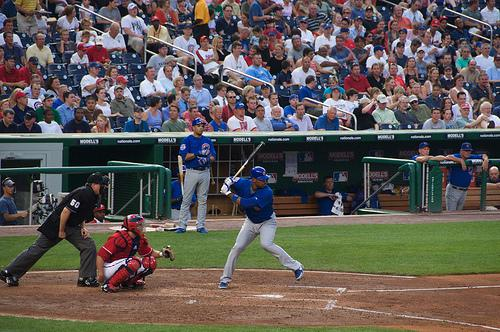Question: where are they at?
Choices:
A. Baseball park.
B. Stadium.
C. Recreational field.
D. Plaza.
Answer with the letter. Answer: A Question: what are they playing?
Choices:
A. Softball.
B. Soccer.
C. Baseball.
D. Football.
Answer with the letter. Answer: C Question: who is holding the bat?
Choices:
A. Player.
B. Batter.
C. A boy.
D. A man.
Answer with the letter. Answer: A Question: how is batter standing?
Choices:
A. Crouching.
B. Up straight.
C. Legs spread apart.
D. On the left.
Answer with the letter. Answer: C 